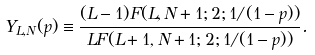Convert formula to latex. <formula><loc_0><loc_0><loc_500><loc_500>Y _ { L , N } ( p ) \equiv \frac { ( L - 1 ) F ( L , N + 1 ; 2 ; 1 / ( 1 - p ) ) } { L F ( L + 1 , N + 1 ; 2 ; 1 / ( 1 - p ) ) } .</formula> 